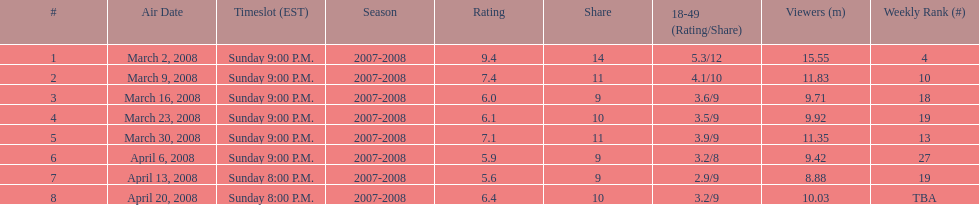Help me parse the entirety of this table. {'header': ['#', 'Air Date', 'Timeslot (EST)', 'Season', 'Rating', 'Share', '18-49 (Rating/Share)', 'Viewers (m)', 'Weekly Rank (#)'], 'rows': [['1', 'March 2, 2008', 'Sunday 9:00 P.M.', '2007-2008', '9.4', '14', '5.3/12', '15.55', '4'], ['2', 'March 9, 2008', 'Sunday 9:00 P.M.', '2007-2008', '7.4', '11', '4.1/10', '11.83', '10'], ['3', 'March 16, 2008', 'Sunday 9:00 P.M.', '2007-2008', '6.0', '9', '3.6/9', '9.71', '18'], ['4', 'March 23, 2008', 'Sunday 9:00 P.M.', '2007-2008', '6.1', '10', '3.5/9', '9.92', '19'], ['5', 'March 30, 2008', 'Sunday 9:00 P.M.', '2007-2008', '7.1', '11', '3.9/9', '11.35', '13'], ['6', 'April 6, 2008', 'Sunday 9:00 P.M.', '2007-2008', '5.9', '9', '3.2/8', '9.42', '27'], ['7', 'April 13, 2008', 'Sunday 8:00 P.M.', '2007-2008', '5.6', '9', '2.9/9', '8.88', '19'], ['8', 'April 20, 2008', 'Sunday 8:00 P.M.', '2007-2008', '6.4', '10', '3.2/9', '10.03', 'TBA']]} Which series achieved the highest viewer ratings? 1. 